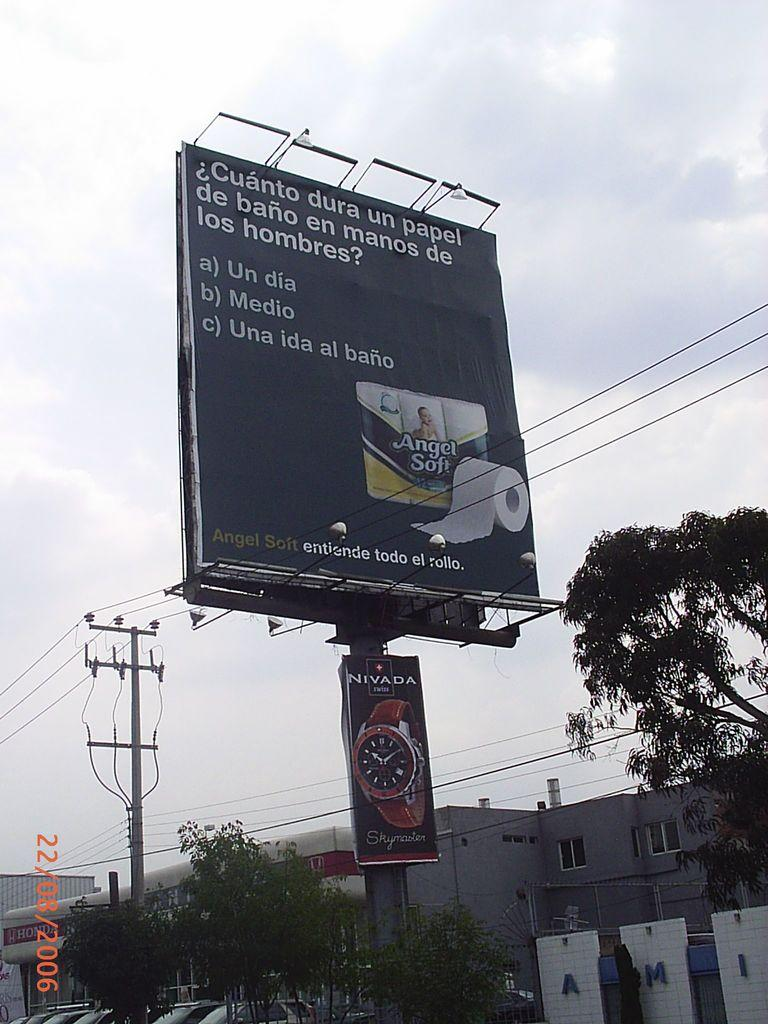Provide a one-sentence caption for the provided image. A toilet paper brand claims to last the whole roll, even in the hands of a man. 